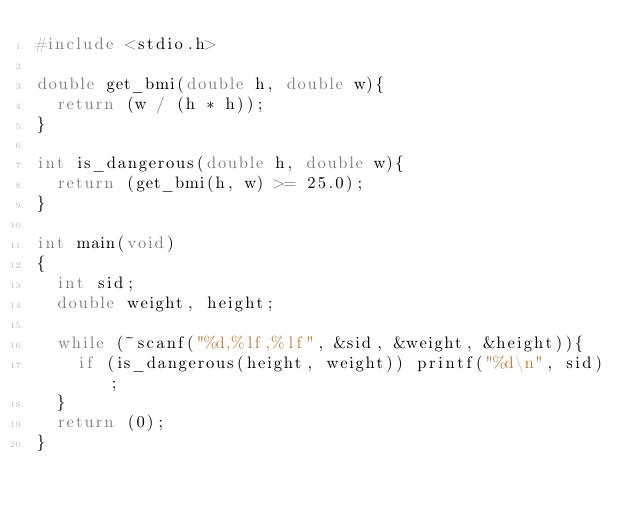<code> <loc_0><loc_0><loc_500><loc_500><_C_>#include <stdio.h>

double get_bmi(double h, double w){
	return (w / (h * h));
}

int is_dangerous(double h, double w){
	return (get_bmi(h, w) >= 25.0);
}

int main(void)
{
	int sid;
	double weight, height;

	while (~scanf("%d,%lf,%lf", &sid, &weight, &height)){
		if (is_dangerous(height, weight)) printf("%d\n", sid);
	}
	return (0);
}</code> 